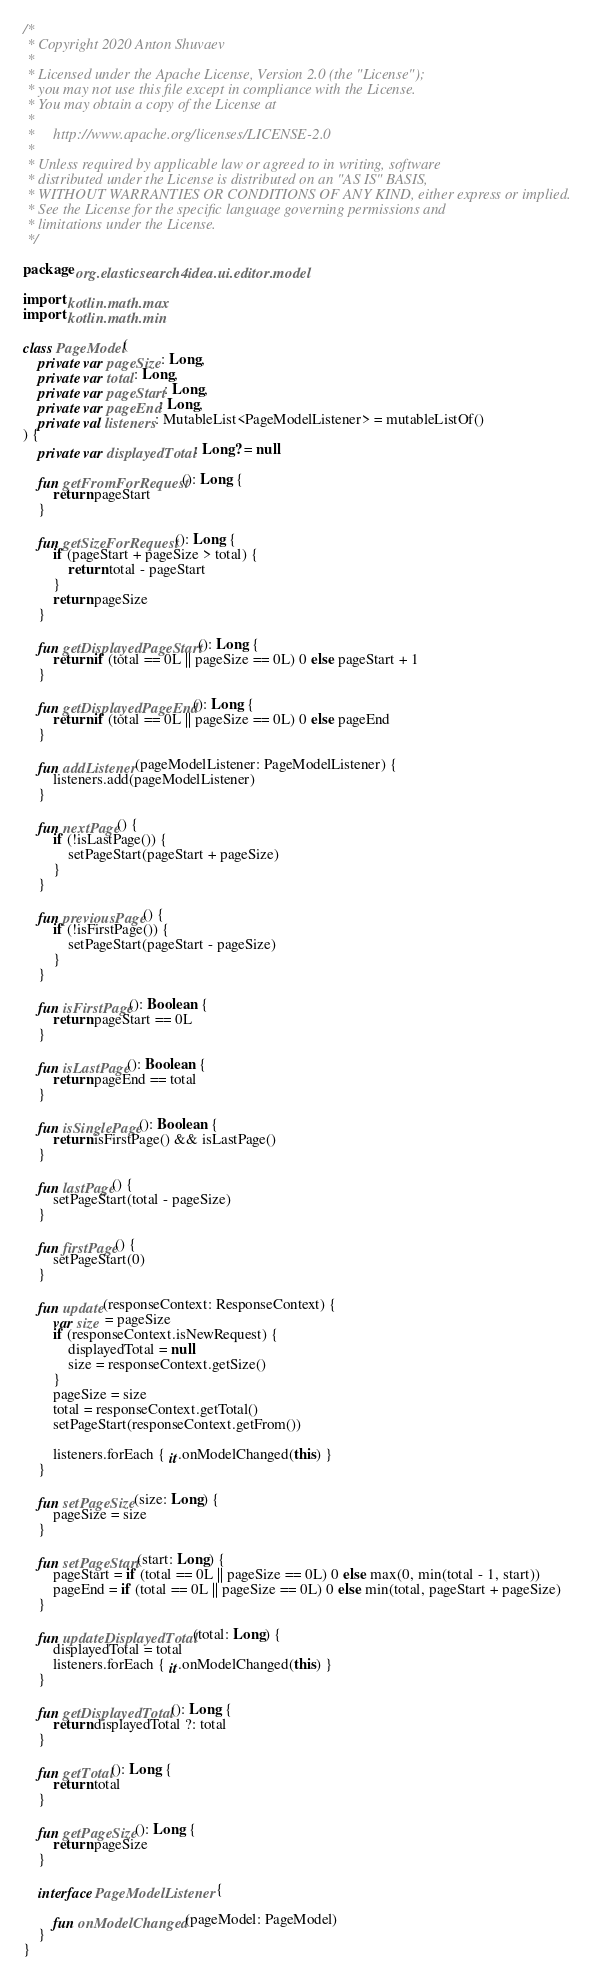<code> <loc_0><loc_0><loc_500><loc_500><_Kotlin_>/*
 * Copyright 2020 Anton Shuvaev
 *
 * Licensed under the Apache License, Version 2.0 (the "License");
 * you may not use this file except in compliance with the License.
 * You may obtain a copy of the License at
 *
 *     http://www.apache.org/licenses/LICENSE-2.0
 *
 * Unless required by applicable law or agreed to in writing, software
 * distributed under the License is distributed on an "AS IS" BASIS,
 * WITHOUT WARRANTIES OR CONDITIONS OF ANY KIND, either express or implied.
 * See the License for the specific language governing permissions and
 * limitations under the License.
 */

package org.elasticsearch4idea.ui.editor.model

import kotlin.math.max
import kotlin.math.min

class PageModel(
    private var pageSize: Long,
    private var total: Long,
    private var pageStart: Long,
    private var pageEnd: Long,
    private val listeners: MutableList<PageModelListener> = mutableListOf()
) {
    private var displayedTotal: Long? = null

    fun getFromForRequest(): Long {
        return pageStart
    }

    fun getSizeForRequest(): Long {
        if (pageStart + pageSize > total) {
            return total - pageStart
        }
        return pageSize
    }

    fun getDisplayedPageStart(): Long {
        return if (total == 0L || pageSize == 0L) 0 else pageStart + 1
    }

    fun getDisplayedPageEnd(): Long {
        return if (total == 0L || pageSize == 0L) 0 else pageEnd
    }

    fun addListener(pageModelListener: PageModelListener) {
        listeners.add(pageModelListener)
    }

    fun nextPage() {
        if (!isLastPage()) {
            setPageStart(pageStart + pageSize)
        }
    }

    fun previousPage() {
        if (!isFirstPage()) {
            setPageStart(pageStart - pageSize)
        }
    }

    fun isFirstPage(): Boolean {
        return pageStart == 0L
    }

    fun isLastPage(): Boolean {
        return pageEnd == total
    }

    fun isSinglePage(): Boolean {
        return isFirstPage() && isLastPage()
    }

    fun lastPage() {
        setPageStart(total - pageSize)
    }

    fun firstPage() {
        setPageStart(0)
    }

    fun update(responseContext: ResponseContext) {
        var size = pageSize
        if (responseContext.isNewRequest) {
            displayedTotal = null
            size = responseContext.getSize()
        }
        pageSize = size
        total = responseContext.getTotal()
        setPageStart(responseContext.getFrom())

        listeners.forEach { it.onModelChanged(this) }
    }

    fun setPageSize(size: Long) {
        pageSize = size
    }

    fun setPageStart(start: Long) {
        pageStart = if (total == 0L || pageSize == 0L) 0 else max(0, min(total - 1, start))
        pageEnd = if (total == 0L || pageSize == 0L) 0 else min(total, pageStart + pageSize)
    }

    fun updateDisplayedTotal(total: Long) {
        displayedTotal = total
        listeners.forEach { it.onModelChanged(this) }
    }

    fun getDisplayedTotal(): Long {
        return displayedTotal ?: total
    }

    fun getTotal(): Long {
        return total
    }

    fun getPageSize(): Long {
        return pageSize
    }

    interface PageModelListener {

        fun onModelChanged(pageModel: PageModel)
    }
}</code> 